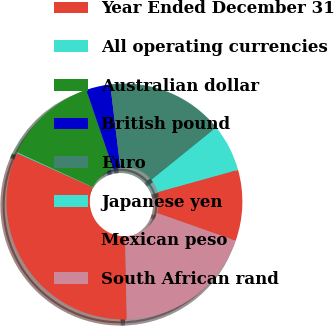<chart> <loc_0><loc_0><loc_500><loc_500><pie_chart><fcel>Year Ended December 31<fcel>All operating currencies<fcel>Australian dollar<fcel>British pound<fcel>Euro<fcel>Japanese yen<fcel>Mexican peso<fcel>South African rand<nl><fcel>32.06%<fcel>0.13%<fcel>12.9%<fcel>3.32%<fcel>16.09%<fcel>6.51%<fcel>9.71%<fcel>19.28%<nl></chart> 